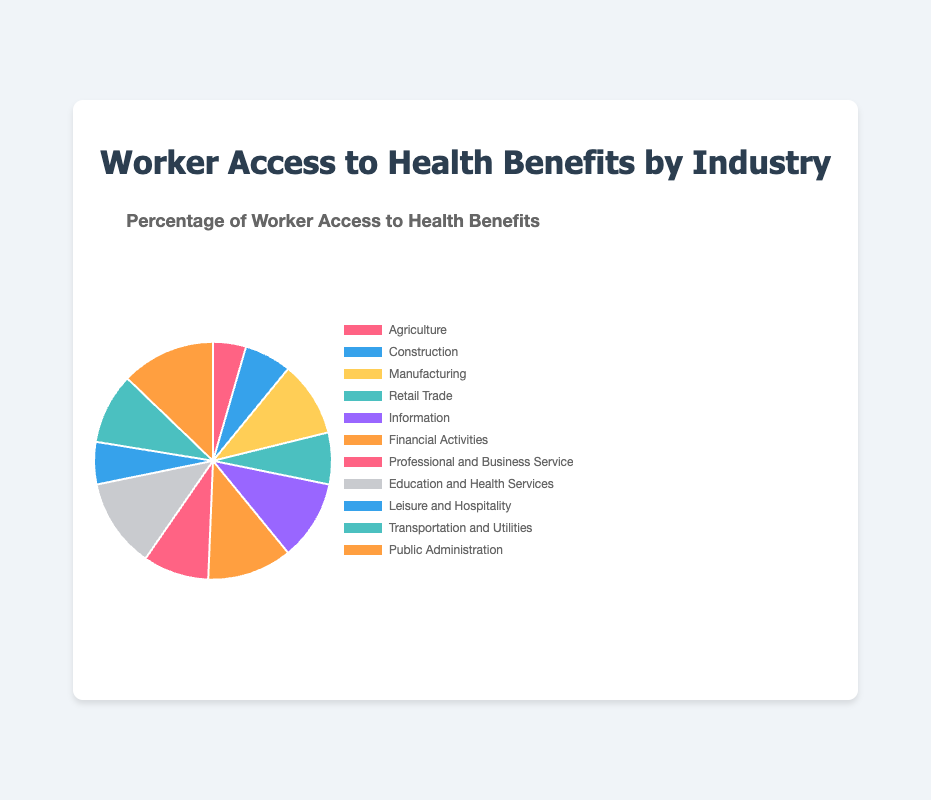Which industry has the highest percentage of worker access to health benefits? The industry with the highest percentage of worker access to health benefits is identified by looking at the sector with the largest slice in the pie chart. Public Administration shows the highest percentage.
Answer: Public Administration Which industry has the lowest percentage of worker access to health benefits? The industry with the lowest percentage is identified by looking at the sector with the smallest slice in the chart. Agriculture shows the lowest percentage.
Answer: Agriculture Compare the percentage of worker access to health benefits between Manufacturing and Retail Trade. Which one is higher? By comparing the sizes of the slices for Manufacturing and Retail Trade, Manufacturing has a notably larger slice, indicating a higher percentage. Manufacturing has 80% while Retail Trade has 55%.
Answer: Manufacturing What is the combined percentage of worker access to health benefits for Financial Activities, Information, and Professional and Business Services? Add the percentages for Financial Activities (90%), Information (85%), and Professional and Business Services (70%): 90 + 85 + 70 = 245%.
Answer: 245% Is Education and Health Services greater than or equal to Leisure and Hospitality in terms of worker access to health benefits? By comparing these two slices in the chart, Education and Health Services has 95% while Leisure and Hospitality has 45%. Thus, Education and Health Services is greater.
Answer: Yes How much larger is the worker access percentage in Public Administration compared to Agriculture? Subtract the percentage of Agriculture (35%) from Public Administration (100%): 100 - 35 = 65%.
Answer: 65% Which industries have less than 50% of worker access to health benefits? Identify the industries with slices smaller than the 50% mark. Only Agriculture fits this criterion.
Answer: Agriculture What is the average percentage of worker access to health benefits across all the industries presented? Add up all percentages and divide by the number of industries. (35 + 50 + 80 + 55 + 85 + 90 + 70 + 95 + 45 + 75 + 100) / 11 = 780 / 11 = 70.91%.
Answer: 70.91% Which slice color represents the Retail Trade industry in the pie chart? The pie chart labels for slices must be compared to their colors, and Retail Trade corresponds with the fourth slice. The fourth slice is yellow.
Answer: Yellow 